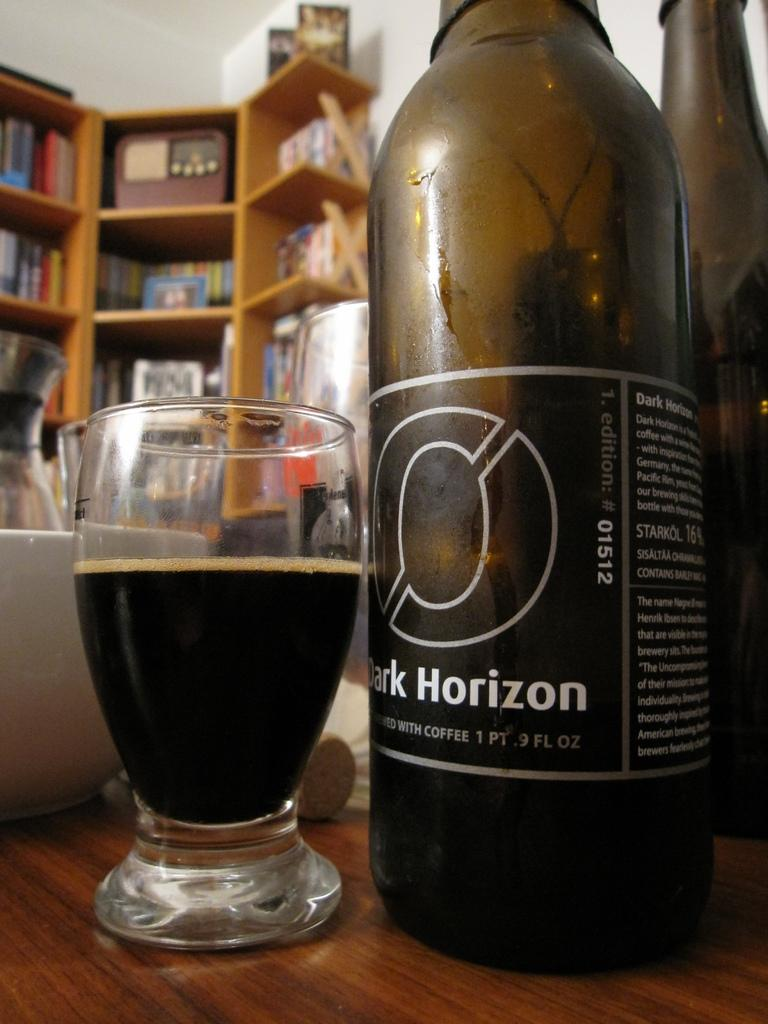What is on the table in the image? There is a bottle and a glass with a drink on the table. What else can be seen on the table? The table appears to be empty except for the bottle and the glass with a drink. What is located on the shelf in the image? There are books on the shelf in the image. Can you see a ticket on the shelf in the image? There is no ticket present on the shelf in the image. Is there a dock visible in the image? There is no dock present in the image. 